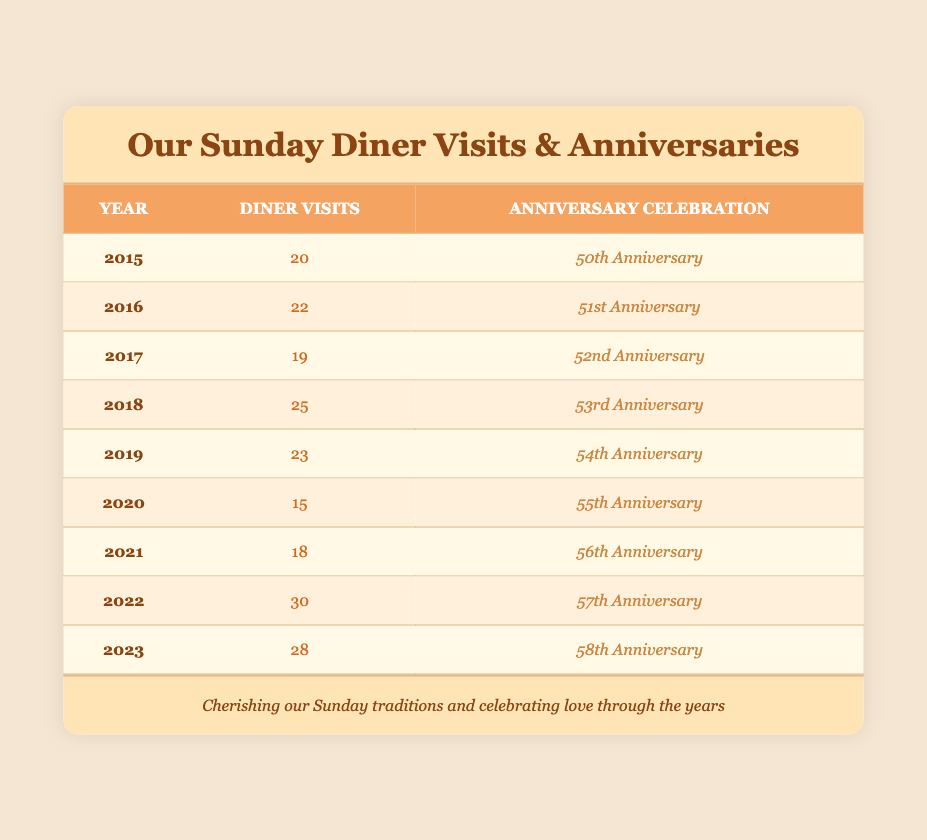What was the diner visit frequency in 2020? The table lists a frequency of 15 diner visits for the year 2020.
Answer: 15 In which year did the couple visit the diner the most frequently? The year 2022 shows the highest frequency of 30 visits.
Answer: 2022 What is the total number of diner visits from 2015 to 2023? Adding the frequencies from each year: 20 + 22 + 19 + 25 + 23 + 15 + 18 + 30 + 28 = 210.
Answer: 210 Did the couple's visits to the diner increase in frequency in 2021 compared to 2020? In 2020, the frequency was 15, and in 2021, it was 18, indicating an increase.
Answer: Yes What was the average frequency of diner visits during the anniversary years listed? To find the average, sum all frequencies (210) and divide by the number of years (9), which gives an average of 23.33.
Answer: 23.33 Was there ever a year when the diner visit frequency was below 20? Yes, the year 2020 had a frequency of 15, which is below 20.
Answer: Yes How many more diner visits were there in 2022 compared to 2019? The frequency in 2022 was 30 and in 2019 it was 23, so 30 - 23 = 7 more visits in 2022 than in 2019.
Answer: 7 What are the anniversary celebrations for the years with more than 25 diner visits? The years 2018 (53rd Anniversary), 2022 (57th Anniversary), and 2023 (58th Anniversary) all had more than 25 visits.
Answer: 53rd Anniversary, 57th Anniversary, 58th Anniversary How many times did the couple visit the diner in years ending in 5? In 2015, they visited 20 times and in 2025, there are no records in the table, thus only 2015 is counted.
Answer: 20 